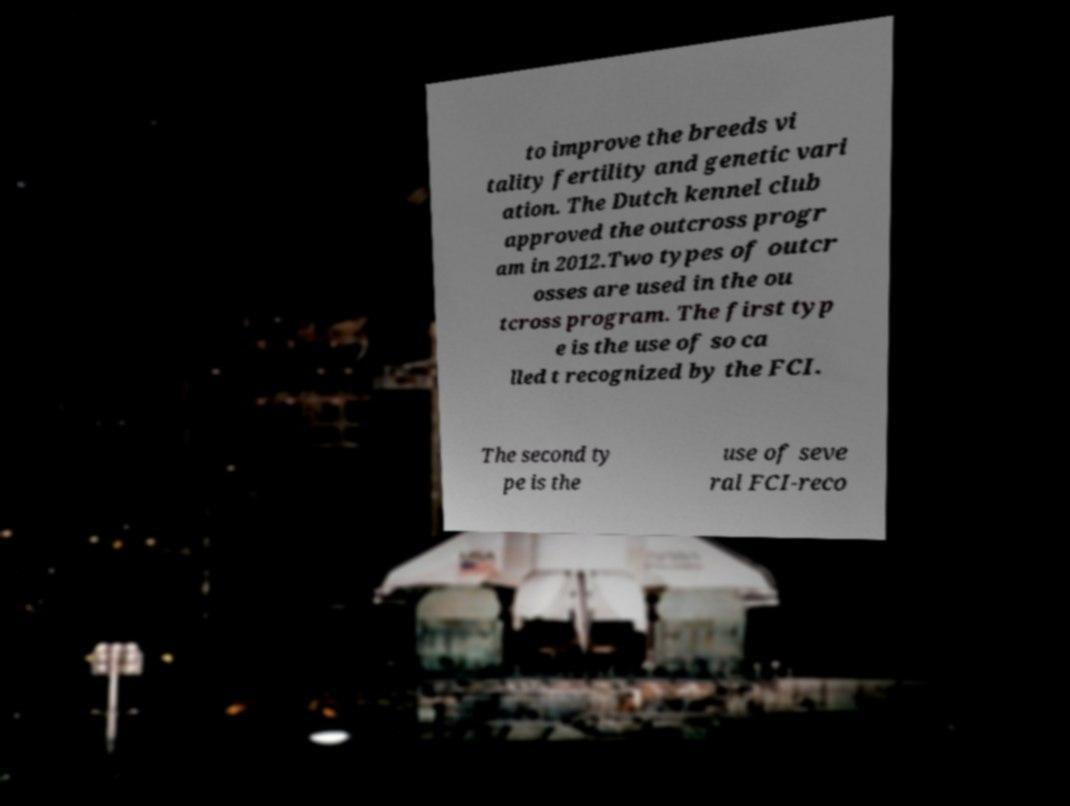Please read and relay the text visible in this image. What does it say? to improve the breeds vi tality fertility and genetic vari ation. The Dutch kennel club approved the outcross progr am in 2012.Two types of outcr osses are used in the ou tcross program. The first typ e is the use of so ca lled t recognized by the FCI. The second ty pe is the use of seve ral FCI-reco 